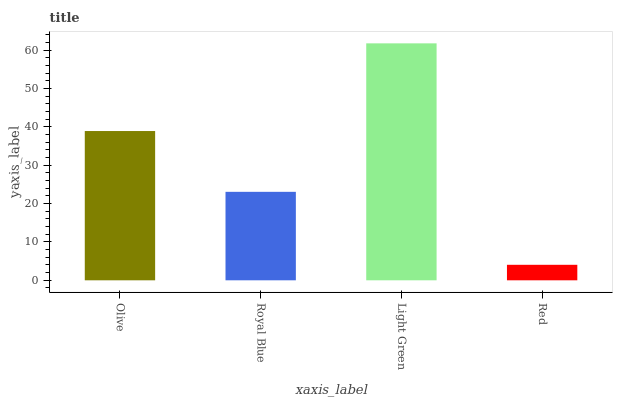Is Red the minimum?
Answer yes or no. Yes. Is Light Green the maximum?
Answer yes or no. Yes. Is Royal Blue the minimum?
Answer yes or no. No. Is Royal Blue the maximum?
Answer yes or no. No. Is Olive greater than Royal Blue?
Answer yes or no. Yes. Is Royal Blue less than Olive?
Answer yes or no. Yes. Is Royal Blue greater than Olive?
Answer yes or no. No. Is Olive less than Royal Blue?
Answer yes or no. No. Is Olive the high median?
Answer yes or no. Yes. Is Royal Blue the low median?
Answer yes or no. Yes. Is Royal Blue the high median?
Answer yes or no. No. Is Light Green the low median?
Answer yes or no. No. 